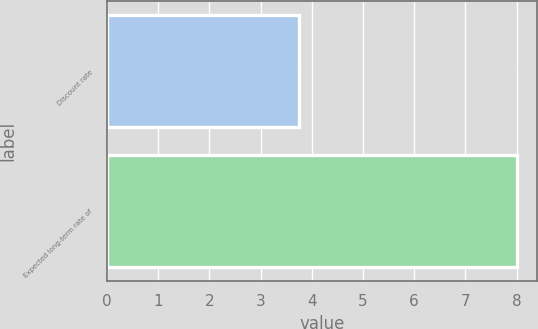Convert chart. <chart><loc_0><loc_0><loc_500><loc_500><bar_chart><fcel>Discount rate<fcel>Expected long-term rate of<nl><fcel>3.75<fcel>8<nl></chart> 